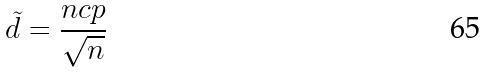Convert formula to latex. <formula><loc_0><loc_0><loc_500><loc_500>\tilde { d } = \frac { n c p } { \sqrt { n } }</formula> 